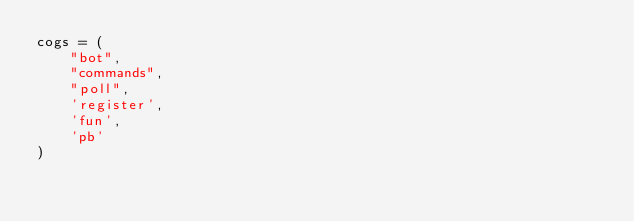<code> <loc_0><loc_0><loc_500><loc_500><_Python_>cogs = (
    "bot",
    "commands",
    "poll",
    'register',
    'fun',
    'pb'
)
</code> 